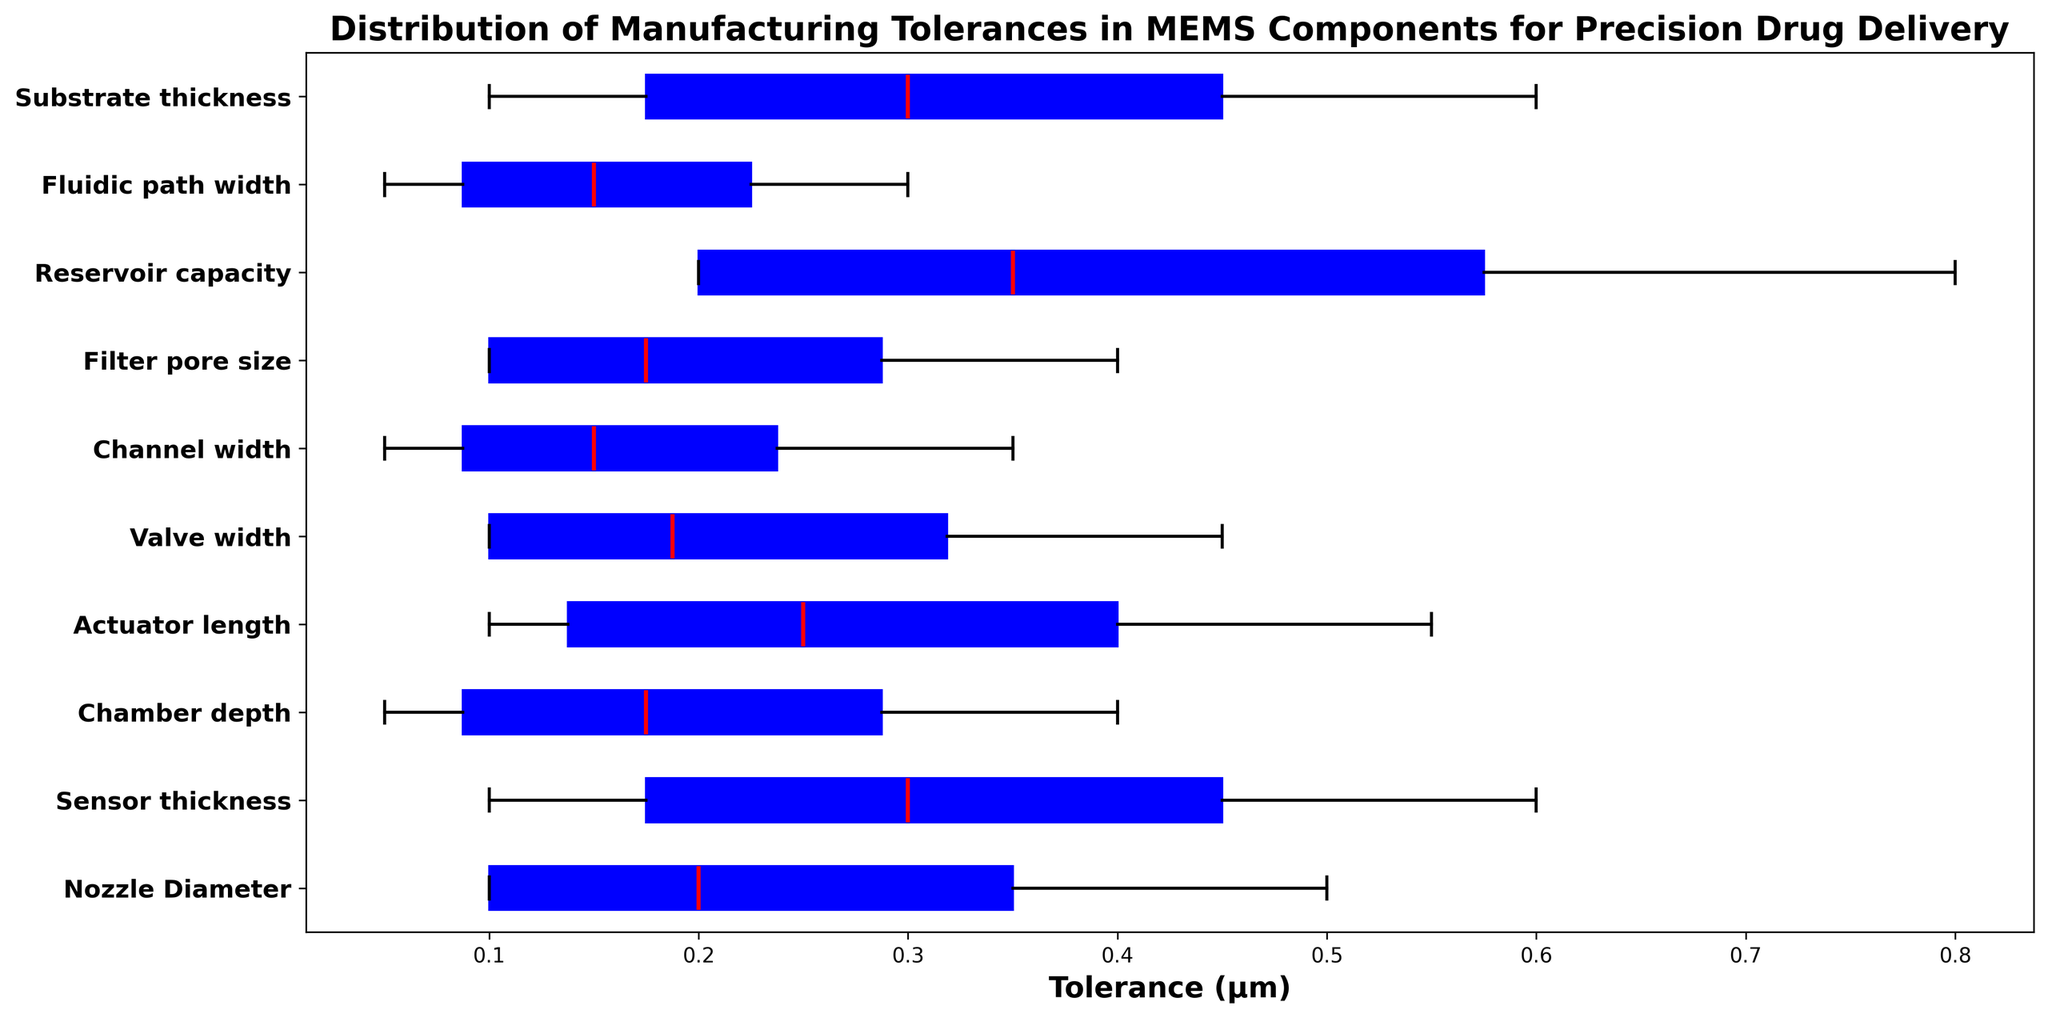What's the median tolerance for the fluidic path width component? The median is shown by the red line in each boxplot. Locate the red line within the box corresponding to the fluidic path width component.
Answer: 0.2 μm Which component has the largest range of tolerances? The range is the difference between the maximum and minimum tolerance values. Identify the component that stretches the most horizontally on the figure.
Answer: Reservoir capacity How does the median tolerance of the nozzle diameter compare with that of the valve width? Locate the red lines for both the nozzle diameter and valve width components, then compare their positions on the x-axis.
Answer: The nozzle diameter's median tolerance is higher than the valve width's Which component has the smallest interquartile range (IQR) for tolerances? The IQR is indicated by the height of the box. Identify the component with the narrowest box in the figure.
Answer: Fluidic path width What is the difference between the maximum tolerance of the chamber depth and the minimum tolerance of the sensor thickness? Locate the maximum tolerance value for the chamber depth and the minimum tolerance value for the sensor thickness from their respective boxes. Subtract the latter from the former.
Answer: 0.2 μm Which component shows the highest median tolerance? Look for the component with the red line (median) positioned furthest to the right on the x-axis.
Answer: Reservoir capacity What is the variance in tolerances for the actuator length component? Variance is a measure of spread. First, note that this data provides the standard deviation as 0.1 μm, and variance is the square of the standard deviation.
Answer: 0.01 (μm)^2 Compare the whisker lengths of the channel width and filter pore size components. Which one has shorter whiskers? Whiskers extend to the minimum and maximum values. Compare the lengths of these lines for the channel width and filter pore size components.
Answer: Channel width Are there any outliers indicated in the boxplot for the substrate thickness component? Outliers are usually denoted by small circles outside the whisker range. Check the plot for such markers in the substrate thickness section.
Answer: No What is the average of the maximum tolerances for all components? Sum up all the maximum tolerance values for each component and divide by the total number of components. Calculation here: (0.5 + 0.6 + 0.4 + 0.55 + 0.45 + 0.35 + 0.4 + 0.8 + 0.3 + 0.6) / 10 = 4.95 / 10
Answer: 0.495 μm 